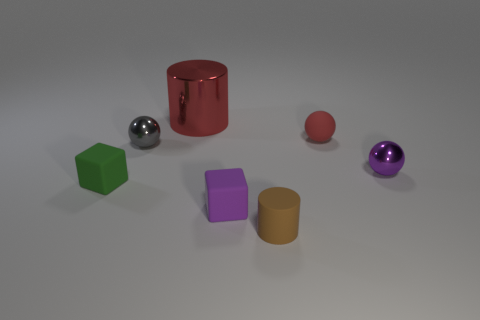There is a purple block; is its size the same as the metallic thing that is behind the red matte thing?
Provide a short and direct response. No. There is a metallic sphere that is to the right of the red matte ball; is there a tiny metallic sphere that is to the left of it?
Provide a short and direct response. Yes. Is there another thing of the same shape as the brown rubber object?
Keep it short and to the point. Yes. What number of purple objects are on the right side of the rubber object that is on the left side of the purple object in front of the small purple metal ball?
Provide a short and direct response. 2. Does the matte sphere have the same color as the cylinder that is behind the gray metallic ball?
Offer a terse response. Yes. What number of things are big red objects that are right of the gray metal thing or matte things that are behind the brown rubber object?
Keep it short and to the point. 4. Is the number of tiny cubes on the left side of the purple metal thing greater than the number of small red spheres to the left of the green rubber object?
Your answer should be very brief. Yes. What is the material of the small cube behind the small rubber cube right of the block that is to the left of the small gray thing?
Give a very brief answer. Rubber. Does the tiny matte object that is on the left side of the big red cylinder have the same shape as the purple thing that is left of the rubber cylinder?
Keep it short and to the point. Yes. Is there a red cylinder that has the same size as the purple metal ball?
Ensure brevity in your answer.  No. 